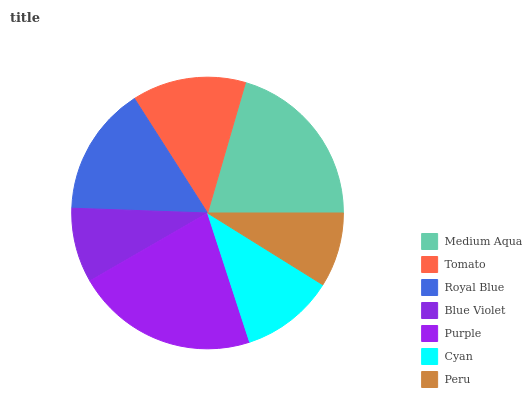Is Peru the minimum?
Answer yes or no. Yes. Is Purple the maximum?
Answer yes or no. Yes. Is Tomato the minimum?
Answer yes or no. No. Is Tomato the maximum?
Answer yes or no. No. Is Medium Aqua greater than Tomato?
Answer yes or no. Yes. Is Tomato less than Medium Aqua?
Answer yes or no. Yes. Is Tomato greater than Medium Aqua?
Answer yes or no. No. Is Medium Aqua less than Tomato?
Answer yes or no. No. Is Tomato the high median?
Answer yes or no. Yes. Is Tomato the low median?
Answer yes or no. Yes. Is Medium Aqua the high median?
Answer yes or no. No. Is Royal Blue the low median?
Answer yes or no. No. 